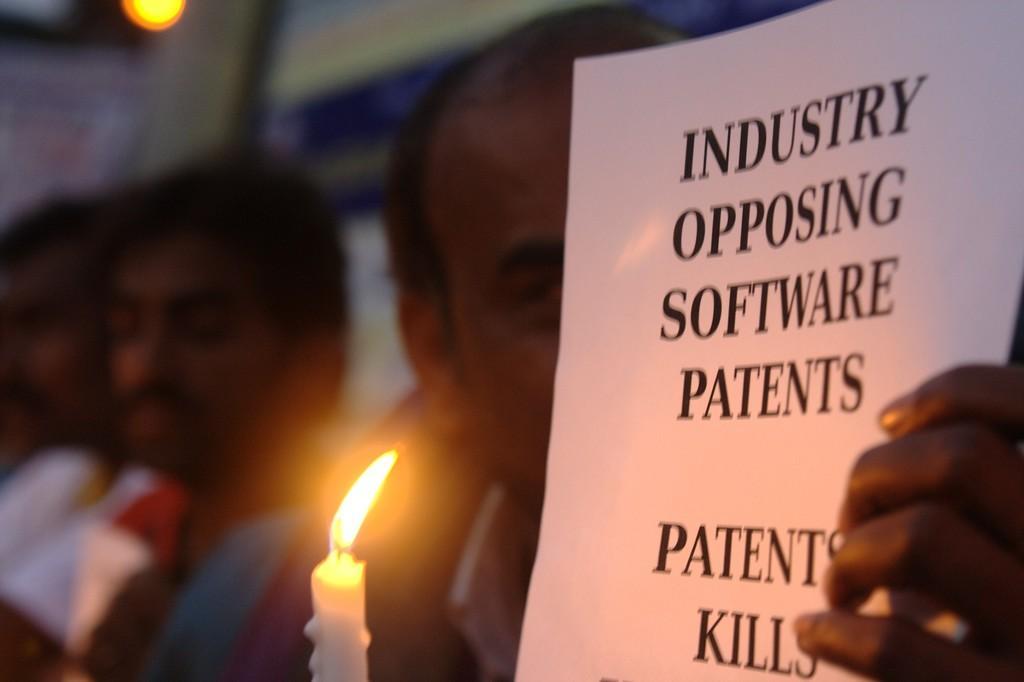How would you summarize this image in a sentence or two? In this image there are a few people, one of them is holding a paper with some text on it and a candle. The background is blurred. 